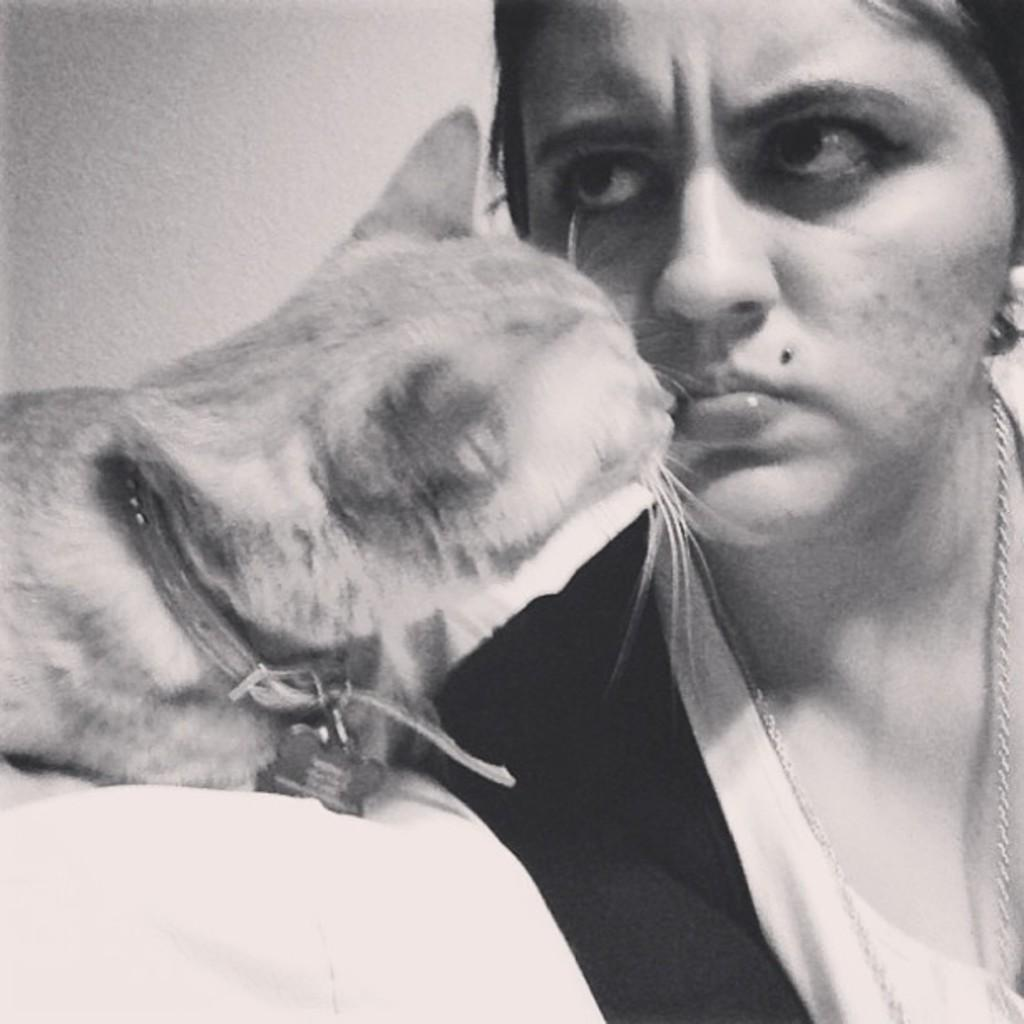Who is present in the image? There is a woman in the image. What animal is also present in the image? There is a cat in the image. Can you describe the cat's appearance? The cat has a belt around its neck. What type of wound can be seen on the cat's paw in the image? There is no wound visible on the cat's paw in the image. 